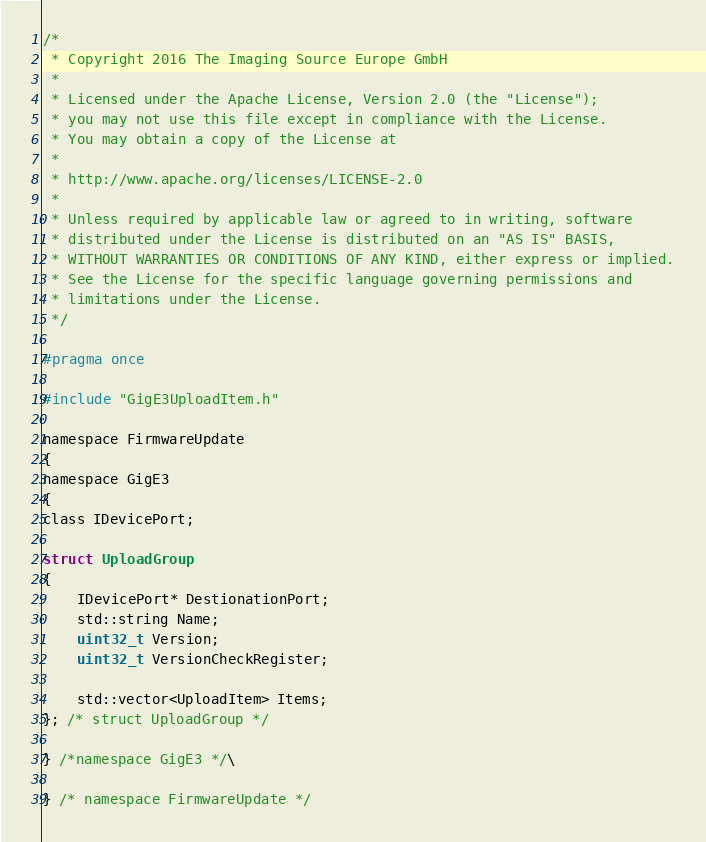<code> <loc_0><loc_0><loc_500><loc_500><_C_>/*
 * Copyright 2016 The Imaging Source Europe GmbH
 *
 * Licensed under the Apache License, Version 2.0 (the "License");
 * you may not use this file except in compliance with the License.
 * You may obtain a copy of the License at
 *
 * http://www.apache.org/licenses/LICENSE-2.0
 *
 * Unless required by applicable law or agreed to in writing, software
 * distributed under the License is distributed on an "AS IS" BASIS,
 * WITHOUT WARRANTIES OR CONDITIONS OF ANY KIND, either express or implied.
 * See the License for the specific language governing permissions and
 * limitations under the License.
 */

#pragma once

#include "GigE3UploadItem.h"

namespace FirmwareUpdate
{
namespace GigE3
{
class IDevicePort;

struct UploadGroup
{
    IDevicePort* DestionationPort;
    std::string Name;
    uint32_t Version;
    uint32_t VersionCheckRegister;

    std::vector<UploadItem> Items;
}; /* struct UploadGroup */

} /*namespace GigE3 */\

} /* namespace FirmwareUpdate */
</code> 